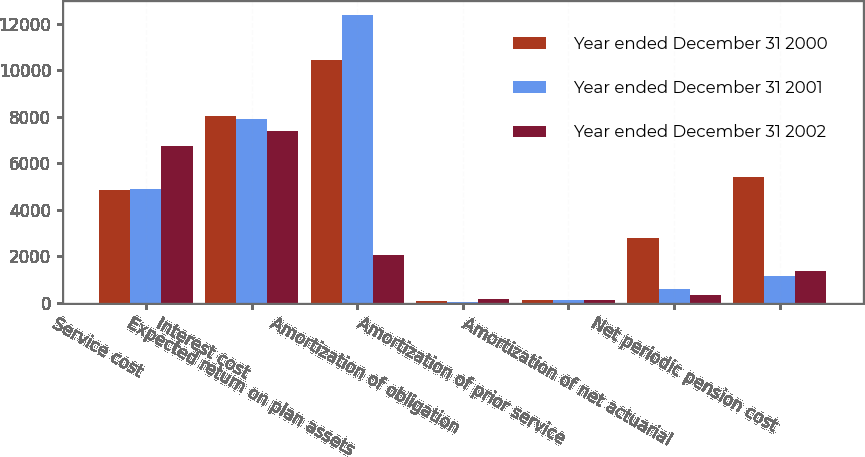<chart> <loc_0><loc_0><loc_500><loc_500><stacked_bar_chart><ecel><fcel>Service cost<fcel>Interest cost<fcel>Expected return on plan assets<fcel>Amortization of obligation<fcel>Amortization of prior service<fcel>Amortization of net actuarial<fcel>Net periodic pension cost<nl><fcel>Year ended December 31 2000<fcel>4841<fcel>8035<fcel>10450<fcel>78<fcel>135<fcel>2779<fcel>5418<nl><fcel>Year ended December 31 2001<fcel>4901<fcel>7912<fcel>12364<fcel>36<fcel>110<fcel>583<fcel>1178<nl><fcel>Year ended December 31 2002<fcel>6754<fcel>7390<fcel>2072.5<fcel>159<fcel>115<fcel>326<fcel>1366<nl></chart> 